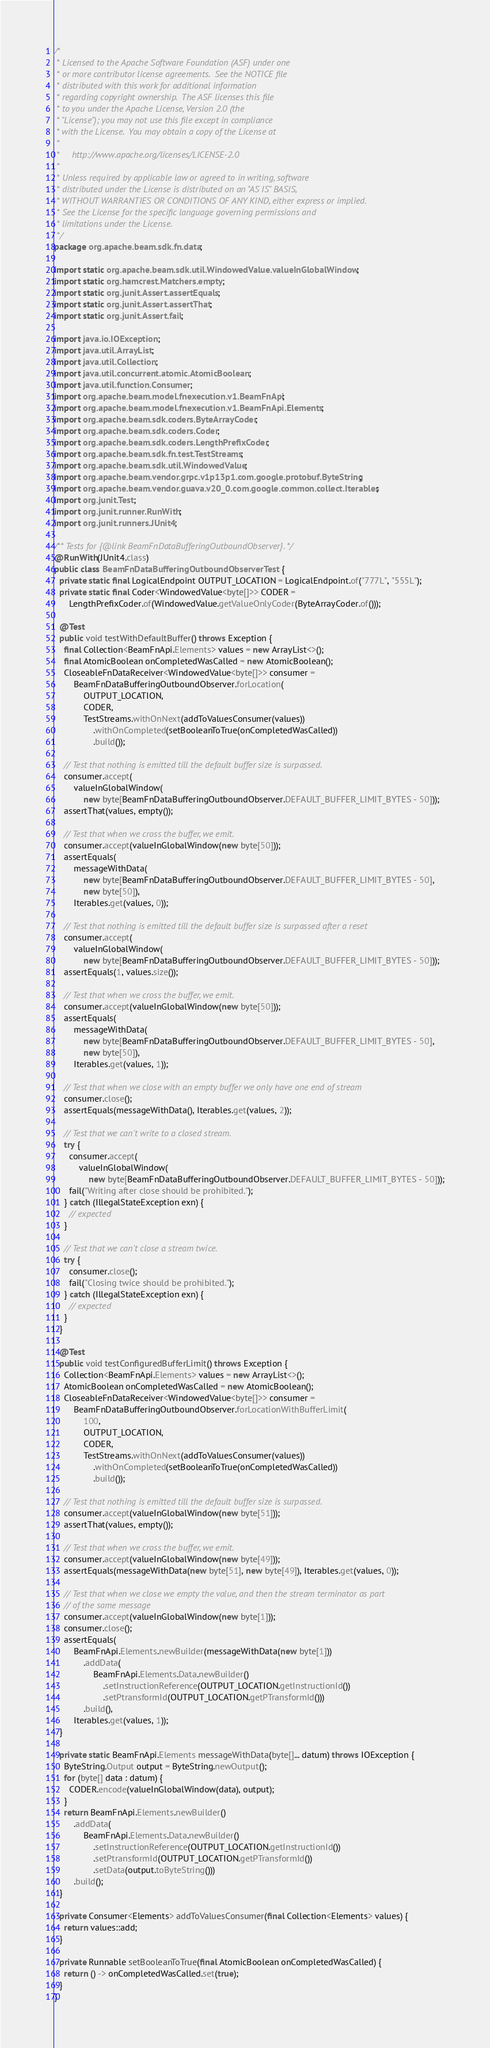Convert code to text. <code><loc_0><loc_0><loc_500><loc_500><_Java_>/*
 * Licensed to the Apache Software Foundation (ASF) under one
 * or more contributor license agreements.  See the NOTICE file
 * distributed with this work for additional information
 * regarding copyright ownership.  The ASF licenses this file
 * to you under the Apache License, Version 2.0 (the
 * "License"); you may not use this file except in compliance
 * with the License.  You may obtain a copy of the License at
 *
 *     http://www.apache.org/licenses/LICENSE-2.0
 *
 * Unless required by applicable law or agreed to in writing, software
 * distributed under the License is distributed on an "AS IS" BASIS,
 * WITHOUT WARRANTIES OR CONDITIONS OF ANY KIND, either express or implied.
 * See the License for the specific language governing permissions and
 * limitations under the License.
 */
package org.apache.beam.sdk.fn.data;

import static org.apache.beam.sdk.util.WindowedValue.valueInGlobalWindow;
import static org.hamcrest.Matchers.empty;
import static org.junit.Assert.assertEquals;
import static org.junit.Assert.assertThat;
import static org.junit.Assert.fail;

import java.io.IOException;
import java.util.ArrayList;
import java.util.Collection;
import java.util.concurrent.atomic.AtomicBoolean;
import java.util.function.Consumer;
import org.apache.beam.model.fnexecution.v1.BeamFnApi;
import org.apache.beam.model.fnexecution.v1.BeamFnApi.Elements;
import org.apache.beam.sdk.coders.ByteArrayCoder;
import org.apache.beam.sdk.coders.Coder;
import org.apache.beam.sdk.coders.LengthPrefixCoder;
import org.apache.beam.sdk.fn.test.TestStreams;
import org.apache.beam.sdk.util.WindowedValue;
import org.apache.beam.vendor.grpc.v1p13p1.com.google.protobuf.ByteString;
import org.apache.beam.vendor.guava.v20_0.com.google.common.collect.Iterables;
import org.junit.Test;
import org.junit.runner.RunWith;
import org.junit.runners.JUnit4;

/** Tests for {@link BeamFnDataBufferingOutboundObserver}. */
@RunWith(JUnit4.class)
public class BeamFnDataBufferingOutboundObserverTest {
  private static final LogicalEndpoint OUTPUT_LOCATION = LogicalEndpoint.of("777L", "555L");
  private static final Coder<WindowedValue<byte[]>> CODER =
      LengthPrefixCoder.of(WindowedValue.getValueOnlyCoder(ByteArrayCoder.of()));

  @Test
  public void testWithDefaultBuffer() throws Exception {
    final Collection<BeamFnApi.Elements> values = new ArrayList<>();
    final AtomicBoolean onCompletedWasCalled = new AtomicBoolean();
    CloseableFnDataReceiver<WindowedValue<byte[]>> consumer =
        BeamFnDataBufferingOutboundObserver.forLocation(
            OUTPUT_LOCATION,
            CODER,
            TestStreams.withOnNext(addToValuesConsumer(values))
                .withOnCompleted(setBooleanToTrue(onCompletedWasCalled))
                .build());

    // Test that nothing is emitted till the default buffer size is surpassed.
    consumer.accept(
        valueInGlobalWindow(
            new byte[BeamFnDataBufferingOutboundObserver.DEFAULT_BUFFER_LIMIT_BYTES - 50]));
    assertThat(values, empty());

    // Test that when we cross the buffer, we emit.
    consumer.accept(valueInGlobalWindow(new byte[50]));
    assertEquals(
        messageWithData(
            new byte[BeamFnDataBufferingOutboundObserver.DEFAULT_BUFFER_LIMIT_BYTES - 50],
            new byte[50]),
        Iterables.get(values, 0));

    // Test that nothing is emitted till the default buffer size is surpassed after a reset
    consumer.accept(
        valueInGlobalWindow(
            new byte[BeamFnDataBufferingOutboundObserver.DEFAULT_BUFFER_LIMIT_BYTES - 50]));
    assertEquals(1, values.size());

    // Test that when we cross the buffer, we emit.
    consumer.accept(valueInGlobalWindow(new byte[50]));
    assertEquals(
        messageWithData(
            new byte[BeamFnDataBufferingOutboundObserver.DEFAULT_BUFFER_LIMIT_BYTES - 50],
            new byte[50]),
        Iterables.get(values, 1));

    // Test that when we close with an empty buffer we only have one end of stream
    consumer.close();
    assertEquals(messageWithData(), Iterables.get(values, 2));

    // Test that we can't write to a closed stream.
    try {
      consumer.accept(
          valueInGlobalWindow(
              new byte[BeamFnDataBufferingOutboundObserver.DEFAULT_BUFFER_LIMIT_BYTES - 50]));
      fail("Writing after close should be prohibited.");
    } catch (IllegalStateException exn) {
      // expected
    }

    // Test that we can't close a stream twice.
    try {
      consumer.close();
      fail("Closing twice should be prohibited.");
    } catch (IllegalStateException exn) {
      // expected
    }
  }

  @Test
  public void testConfiguredBufferLimit() throws Exception {
    Collection<BeamFnApi.Elements> values = new ArrayList<>();
    AtomicBoolean onCompletedWasCalled = new AtomicBoolean();
    CloseableFnDataReceiver<WindowedValue<byte[]>> consumer =
        BeamFnDataBufferingOutboundObserver.forLocationWithBufferLimit(
            100,
            OUTPUT_LOCATION,
            CODER,
            TestStreams.withOnNext(addToValuesConsumer(values))
                .withOnCompleted(setBooleanToTrue(onCompletedWasCalled))
                .build());

    // Test that nothing is emitted till the default buffer size is surpassed.
    consumer.accept(valueInGlobalWindow(new byte[51]));
    assertThat(values, empty());

    // Test that when we cross the buffer, we emit.
    consumer.accept(valueInGlobalWindow(new byte[49]));
    assertEquals(messageWithData(new byte[51], new byte[49]), Iterables.get(values, 0));

    // Test that when we close we empty the value, and then the stream terminator as part
    // of the same message
    consumer.accept(valueInGlobalWindow(new byte[1]));
    consumer.close();
    assertEquals(
        BeamFnApi.Elements.newBuilder(messageWithData(new byte[1]))
            .addData(
                BeamFnApi.Elements.Data.newBuilder()
                    .setInstructionReference(OUTPUT_LOCATION.getInstructionId())
                    .setPtransformId(OUTPUT_LOCATION.getPTransformId()))
            .build(),
        Iterables.get(values, 1));
  }

  private static BeamFnApi.Elements messageWithData(byte[]... datum) throws IOException {
    ByteString.Output output = ByteString.newOutput();
    for (byte[] data : datum) {
      CODER.encode(valueInGlobalWindow(data), output);
    }
    return BeamFnApi.Elements.newBuilder()
        .addData(
            BeamFnApi.Elements.Data.newBuilder()
                .setInstructionReference(OUTPUT_LOCATION.getInstructionId())
                .setPtransformId(OUTPUT_LOCATION.getPTransformId())
                .setData(output.toByteString()))
        .build();
  }

  private Consumer<Elements> addToValuesConsumer(final Collection<Elements> values) {
    return values::add;
  }

  private Runnable setBooleanToTrue(final AtomicBoolean onCompletedWasCalled) {
    return () -> onCompletedWasCalled.set(true);
  }
}
</code> 